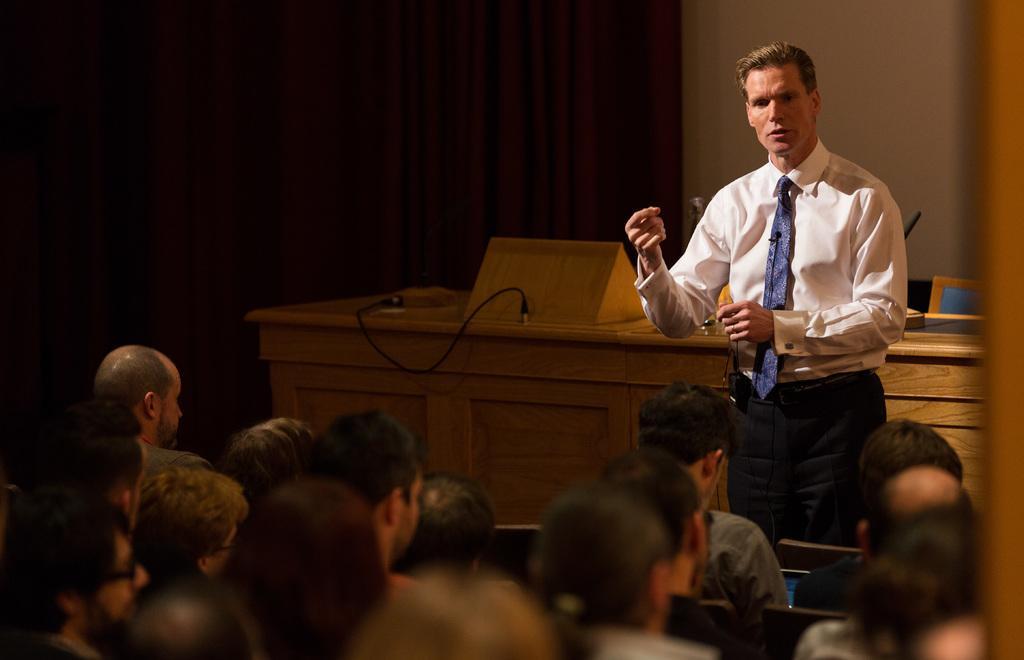How would you summarize this image in a sentence or two? In this image, I can see a man standing and a group of people sitting on the chairs. Behind the man, there is a wooden table with a cable and few other things. In the background, I can see a curtain hanging and there is a wall. 